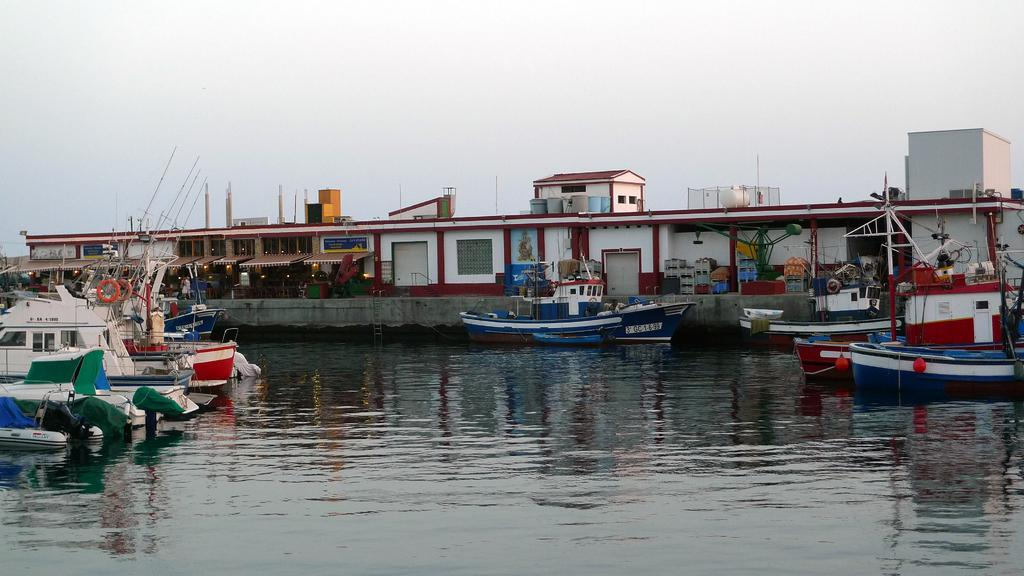What can be seen in the image that is used for transportation on water? There are boats in the image that are used for transportation on water. Where are the boats located in the image? The boats are on the water in the image. What can be seen in the boats that might be used for fishing? There are poles in these boats that might be used for fishing. What color are the objects in the boats? There are orange objects in these boats. What type of structures can be seen in the background of the image? There are houses visible in the image. What can be seen in the houses that provide illumination? There are lights in these houses. What type of kettle can be seen in the image? There is no kettle present in the image. What shape is the rake in the image? There is no rake present in the image. 